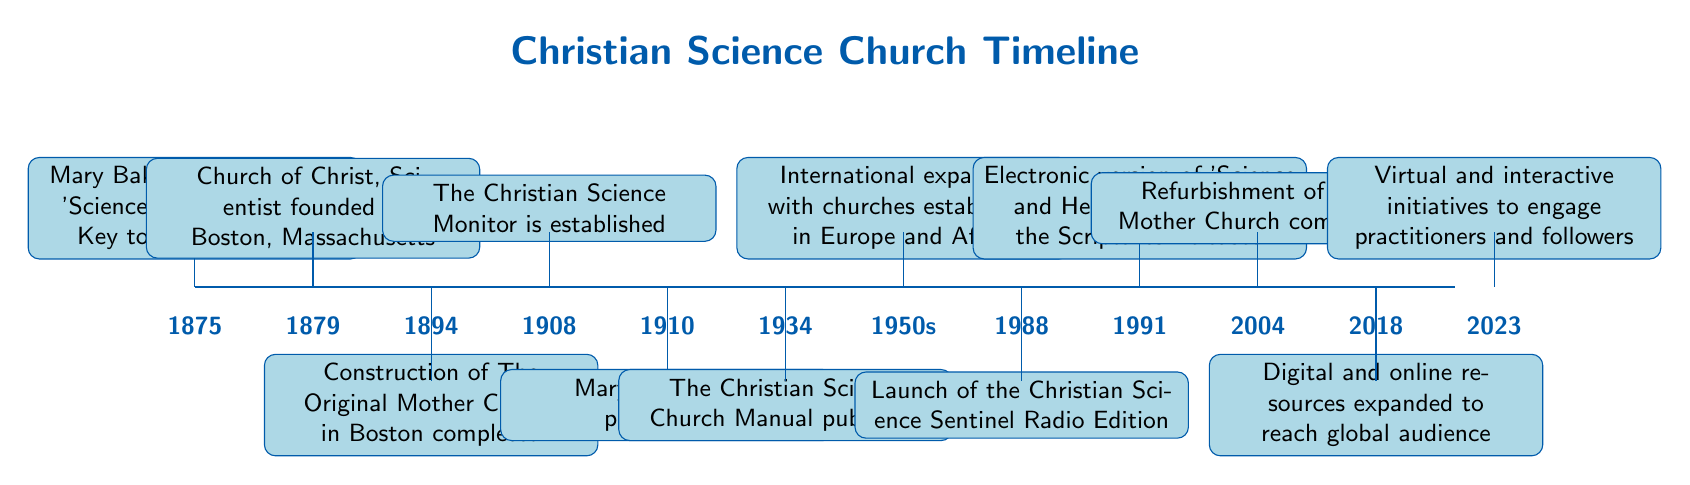What year was the Church of Christ, Scientist founded? The diagram shows a timeline with the event "Church of Christ, Scientist founded" marked at the year 1879.
Answer: 1879 What event occurred in 1910? In 1910, the timeline indicates that "Mary Baker Eddy passes away."
Answer: Mary Baker Eddy passes away How many major events are listed before 1950? By counting the events on the timeline before 1950, we see there are six events (up to 1934).
Answer: 6 What significant publication was released in 1934? The diagram mentions that in 1934, "The Christian Science Church Manual published" was a key event.
Answer: The Christian Science Church Manual published Which event follows the establishment of The Christian Science Monitor? The event that follows "The Christian Science Monitor is established" (in 1908) is "Mary Baker Eddy passes away" (in 1910).
Answer: Mary Baker Eddy passes away In what year was the electronic version of 'Science and Health with Key to the Scriptures' released? The timeline shows that the electronic version was released in the year 1991.
Answer: 1991 What type of initiatives began in 2023? According to the timeline, in 2023, "Virtual and interactive initiatives to engage practitioners and followers" began.
Answer: Virtual and interactive initiatives Which event marks the refurbishment of The Mother Church? The refurbishment of The Mother Church is marked specifically in 2004 on the timeline.
Answer: Refurbishment of The Mother Church completed What was launched in 1988 according to the timeline? The timeline indicates that in 1988, "Launch of the Christian Science Sentinel Radio Edition" was the notable event.
Answer: Launch of the Christian Science Sentinel Radio Edition 